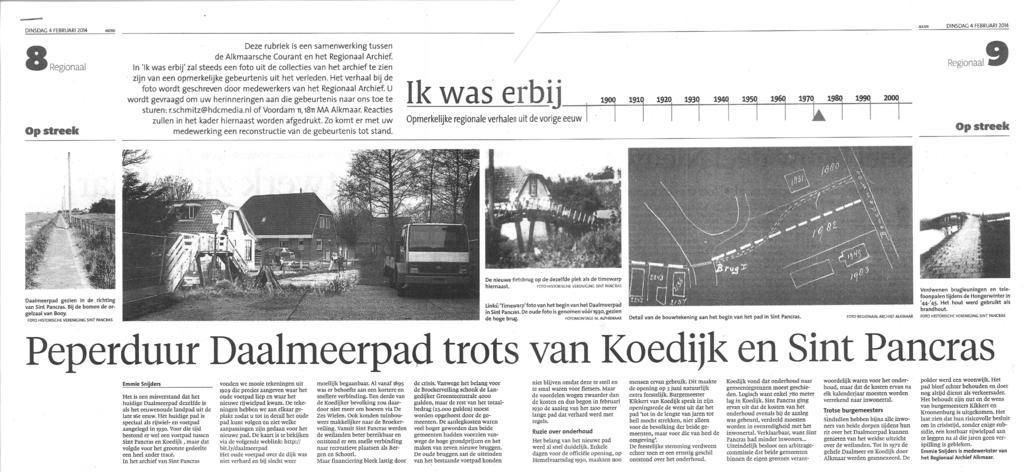Please provide a concise description of this image. This image consists of a newspaper with a text and a few images on it. 